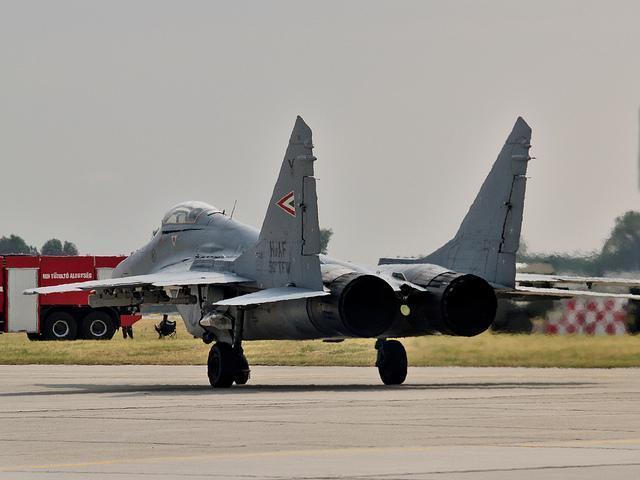How many planes?
Give a very brief answer. 1. How many of the buses visible on the street are two story?
Give a very brief answer. 0. 